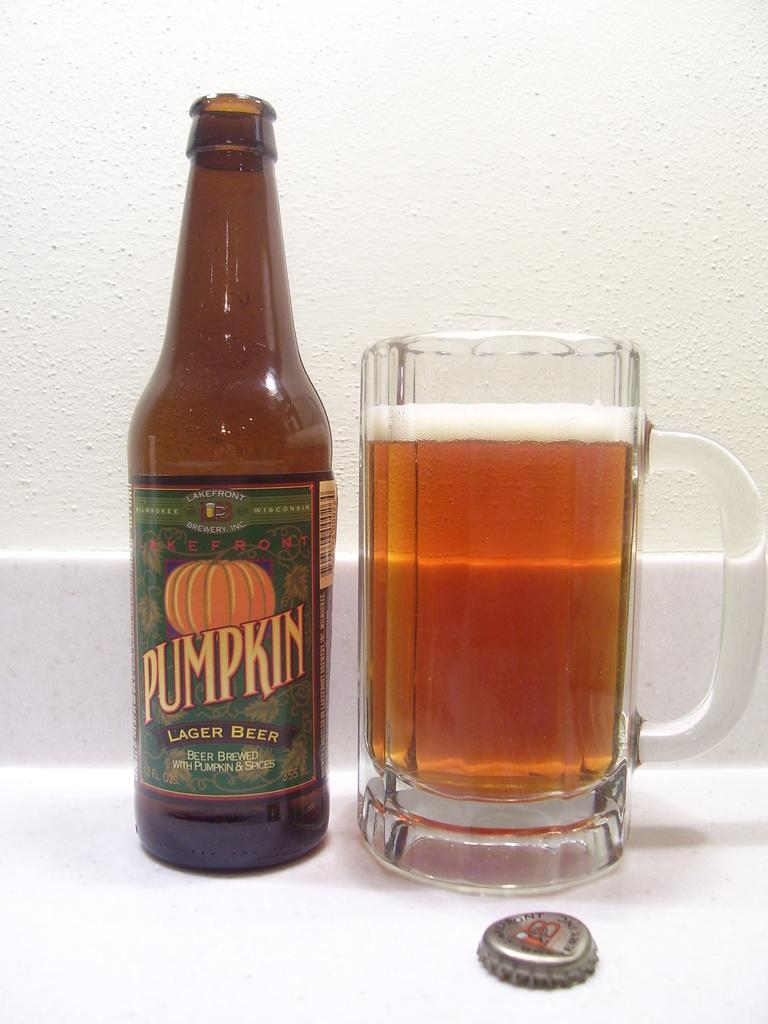What objects are on the table in the image? There is a bottle and a glass on the table in the image. What is the purpose of the bottle and the glass? The bottle and the glass are likely used for holding or serving a beverage. What can be seen in the background of the image? There is a wall visible in the background of the image. Where is the bucket located in the image? There is no bucket present in the image. How many flies can be seen buzzing around the glass in the image? There are no flies present in the image. 